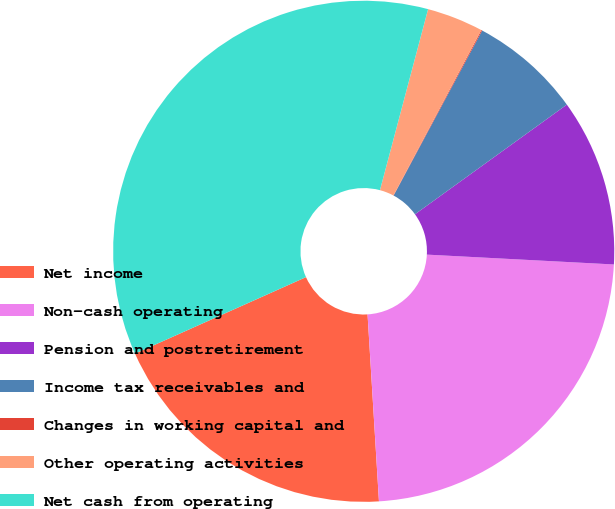Convert chart. <chart><loc_0><loc_0><loc_500><loc_500><pie_chart><fcel>Net income<fcel>Non-cash operating<fcel>Pension and postretirement<fcel>Income tax receivables and<fcel>Changes in working capital and<fcel>Other operating activities<fcel>Net cash from operating<nl><fcel>19.27%<fcel>23.19%<fcel>10.79%<fcel>7.21%<fcel>0.06%<fcel>3.64%<fcel>35.83%<nl></chart> 